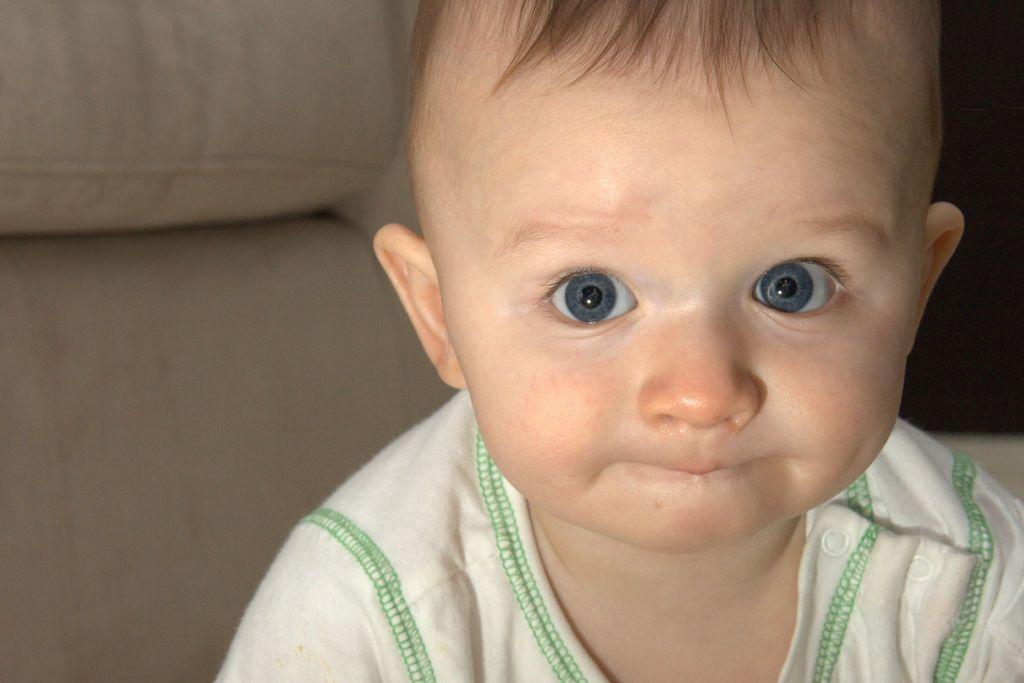In one or two sentences, can you explain what this image depicts? In this picture we can observe a baby wearing white color dress. Behind the baby we can observe the sofa which is in cream color. 